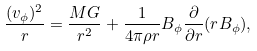<formula> <loc_0><loc_0><loc_500><loc_500>\frac { ( v _ { \phi } ) ^ { 2 } } { r } = \frac { M G } { r ^ { 2 } } + \frac { 1 } { 4 \pi \rho r } B _ { \phi } \frac { \partial } { \partial r } ( r B _ { \phi } ) ,</formula> 